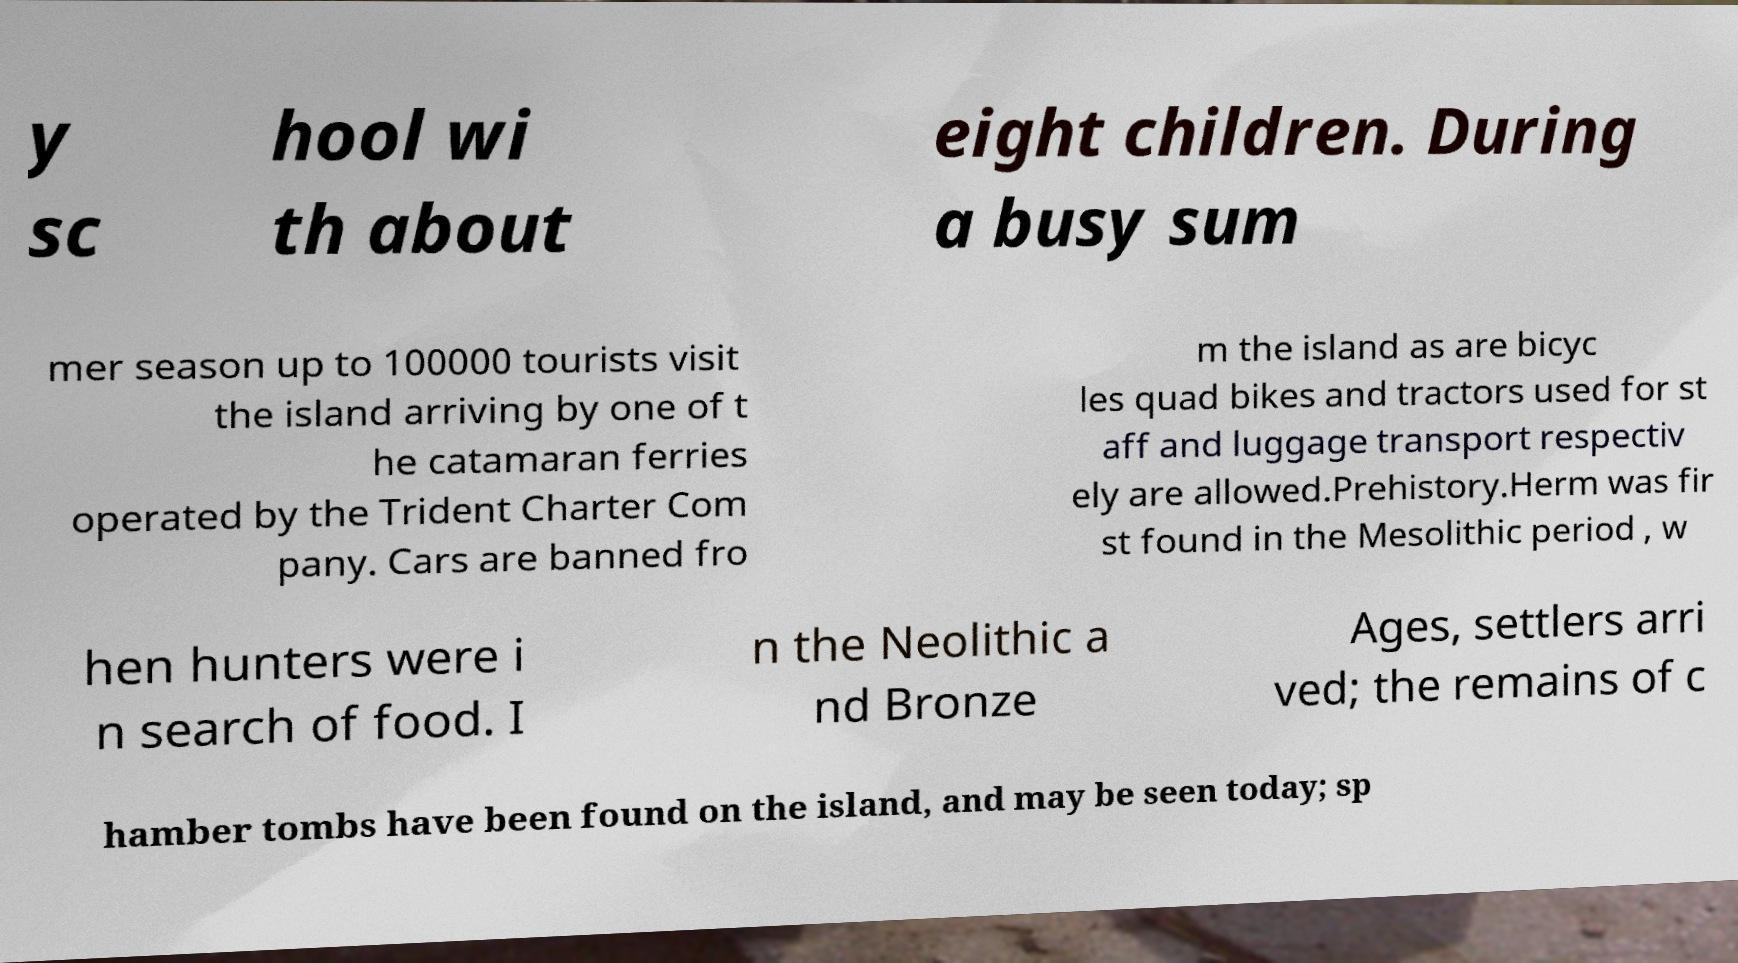I need the written content from this picture converted into text. Can you do that? y sc hool wi th about eight children. During a busy sum mer season up to 100000 tourists visit the island arriving by one of t he catamaran ferries operated by the Trident Charter Com pany. Cars are banned fro m the island as are bicyc les quad bikes and tractors used for st aff and luggage transport respectiv ely are allowed.Prehistory.Herm was fir st found in the Mesolithic period , w hen hunters were i n search of food. I n the Neolithic a nd Bronze Ages, settlers arri ved; the remains of c hamber tombs have been found on the island, and may be seen today; sp 